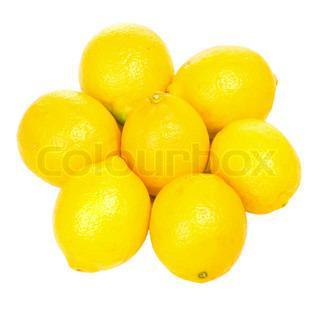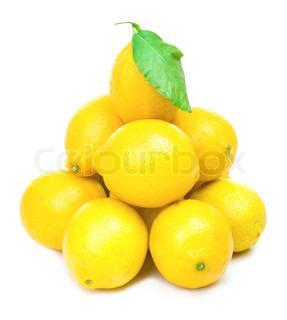The first image is the image on the left, the second image is the image on the right. Evaluate the accuracy of this statement regarding the images: "In at least one image there is at least one image with a full lemon and a lemon half cut horizontal.". Is it true? Answer yes or no. No. The first image is the image on the left, the second image is the image on the right. For the images shown, is this caption "Each image includes at least one whole lemon and one half lemon." true? Answer yes or no. No. 